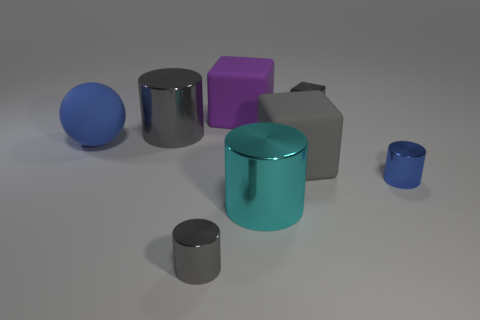Add 1 small gray objects. How many objects exist? 9 Subtract all gray blocks. How many blocks are left? 1 Subtract 2 cylinders. How many cylinders are left? 2 Subtract all blue cylinders. How many cylinders are left? 3 Subtract all brown cylinders. Subtract all brown blocks. How many cylinders are left? 4 Subtract all cubes. How many objects are left? 5 Add 8 small blue metal cylinders. How many small blue metal cylinders exist? 9 Subtract 0 purple spheres. How many objects are left? 8 Subtract all small blue cylinders. Subtract all big matte objects. How many objects are left? 4 Add 6 large purple rubber cubes. How many large purple rubber cubes are left? 7 